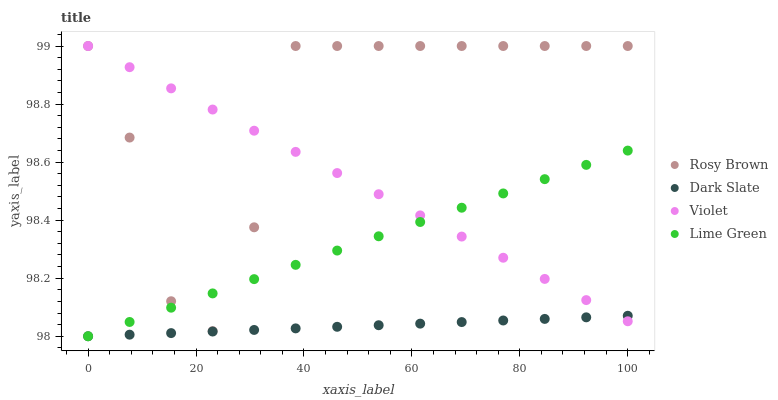Does Dark Slate have the minimum area under the curve?
Answer yes or no. Yes. Does Rosy Brown have the maximum area under the curve?
Answer yes or no. Yes. Does Lime Green have the minimum area under the curve?
Answer yes or no. No. Does Lime Green have the maximum area under the curve?
Answer yes or no. No. Is Lime Green the smoothest?
Answer yes or no. Yes. Is Rosy Brown the roughest?
Answer yes or no. Yes. Is Rosy Brown the smoothest?
Answer yes or no. No. Is Lime Green the roughest?
Answer yes or no. No. Does Dark Slate have the lowest value?
Answer yes or no. Yes. Does Rosy Brown have the lowest value?
Answer yes or no. No. Does Violet have the highest value?
Answer yes or no. Yes. Does Lime Green have the highest value?
Answer yes or no. No. Is Dark Slate less than Rosy Brown?
Answer yes or no. Yes. Is Rosy Brown greater than Dark Slate?
Answer yes or no. Yes. Does Lime Green intersect Dark Slate?
Answer yes or no. Yes. Is Lime Green less than Dark Slate?
Answer yes or no. No. Is Lime Green greater than Dark Slate?
Answer yes or no. No. Does Dark Slate intersect Rosy Brown?
Answer yes or no. No. 